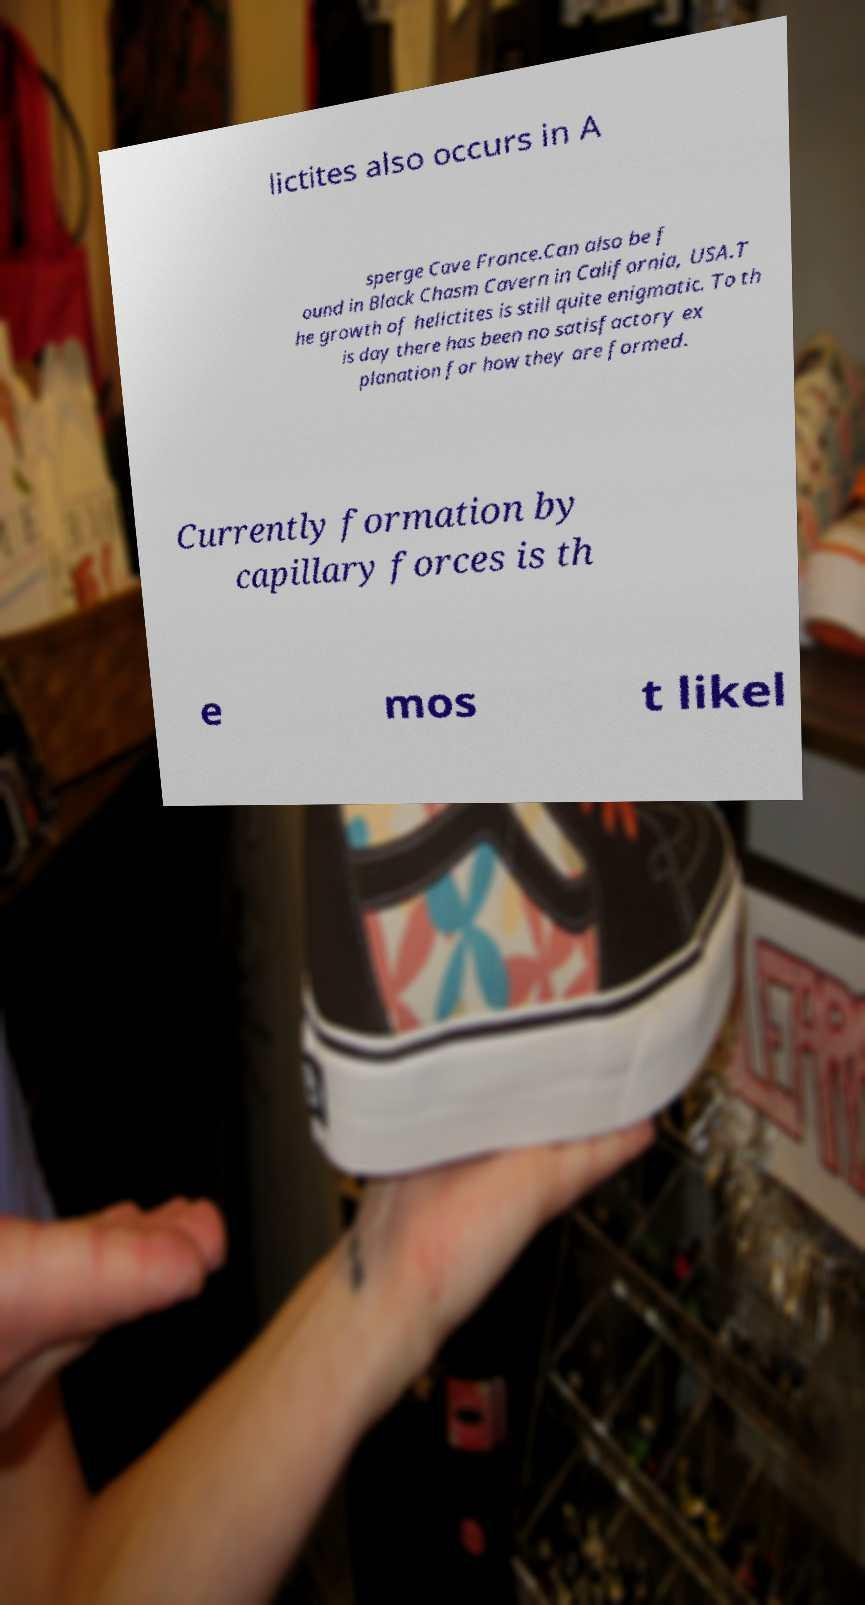What messages or text are displayed in this image? I need them in a readable, typed format. lictites also occurs in A sperge Cave France.Can also be f ound in Black Chasm Cavern in California, USA.T he growth of helictites is still quite enigmatic. To th is day there has been no satisfactory ex planation for how they are formed. Currently formation by capillary forces is th e mos t likel 